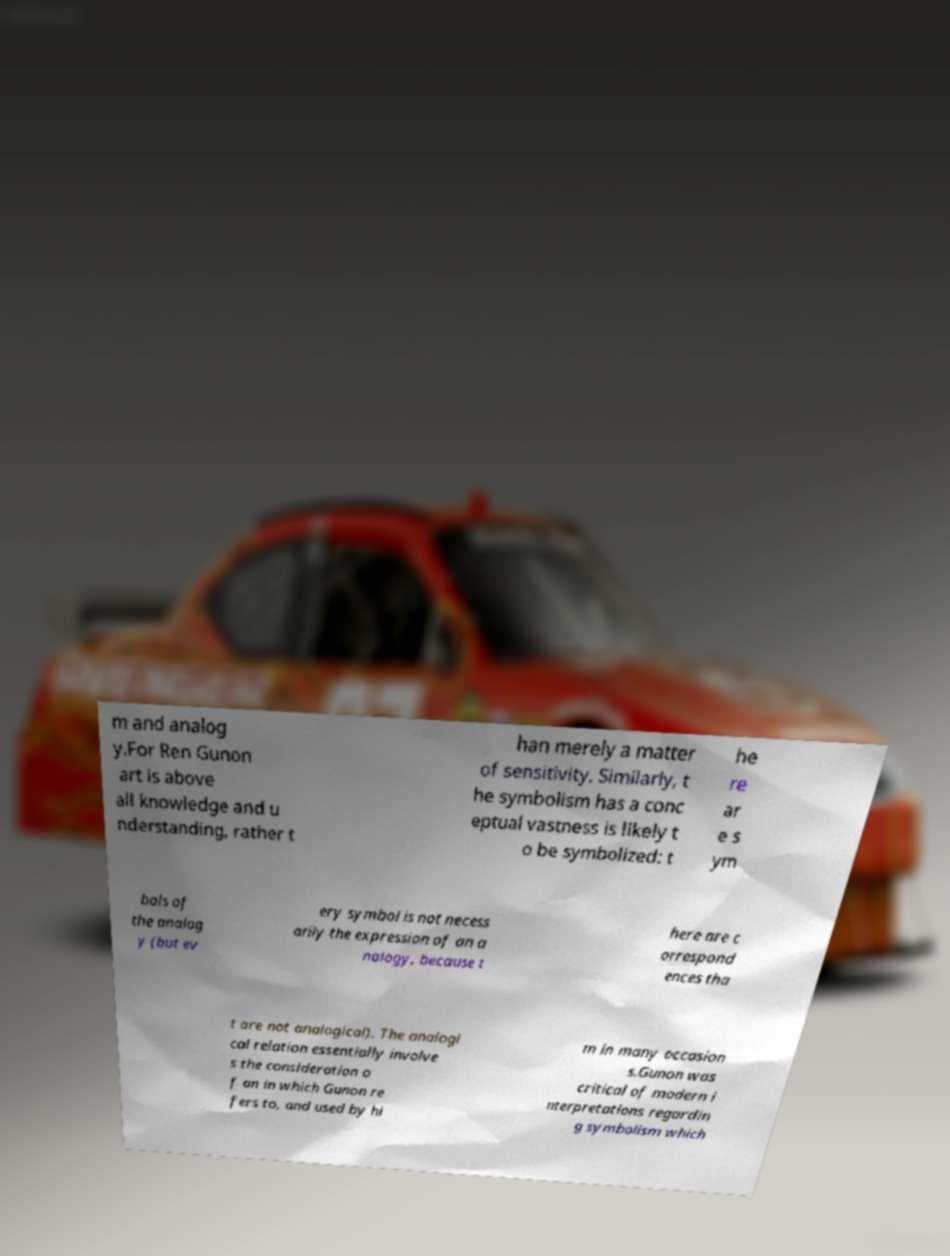What messages or text are displayed in this image? I need them in a readable, typed format. m and analog y.For Ren Gunon art is above all knowledge and u nderstanding, rather t han merely a matter of sensitivity. Similarly, t he symbolism has a conc eptual vastness is likely t o be symbolized: t he re ar e s ym bols of the analog y (but ev ery symbol is not necess arily the expression of an a nalogy, because t here are c orrespond ences tha t are not analogical). The analogi cal relation essentially involve s the consideration o f an in which Gunon re fers to, and used by hi m in many occasion s.Gunon was critical of modern i nterpretations regardin g symbolism which 